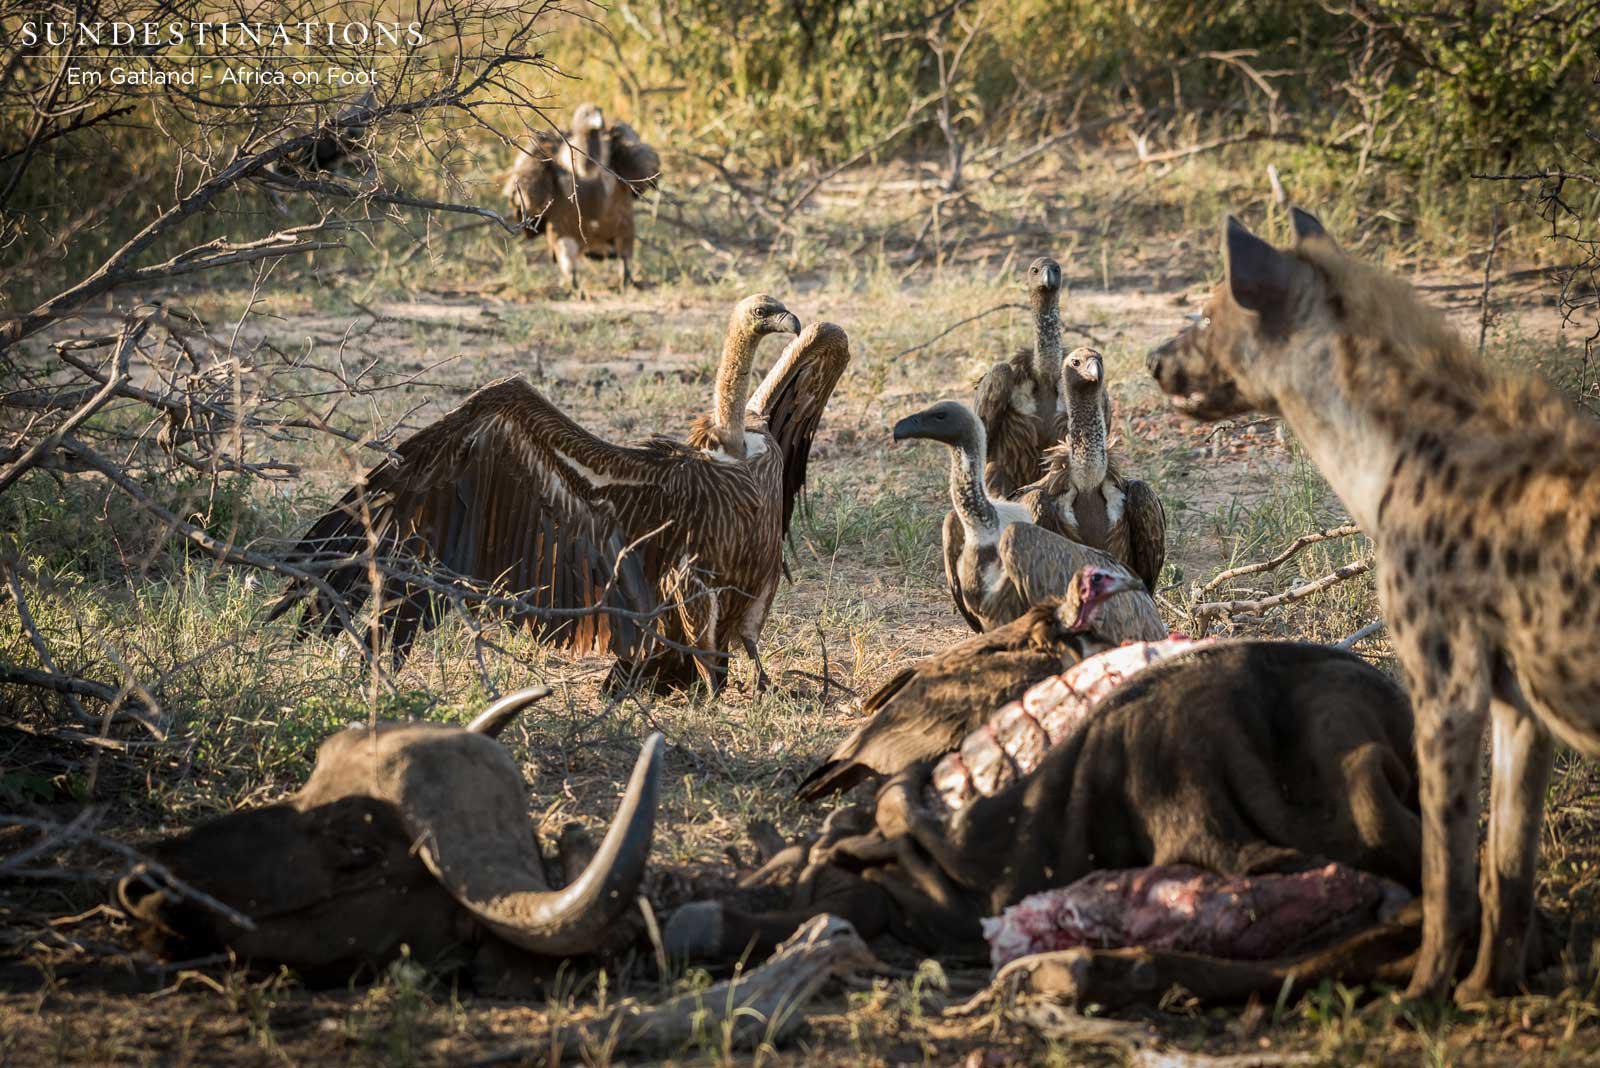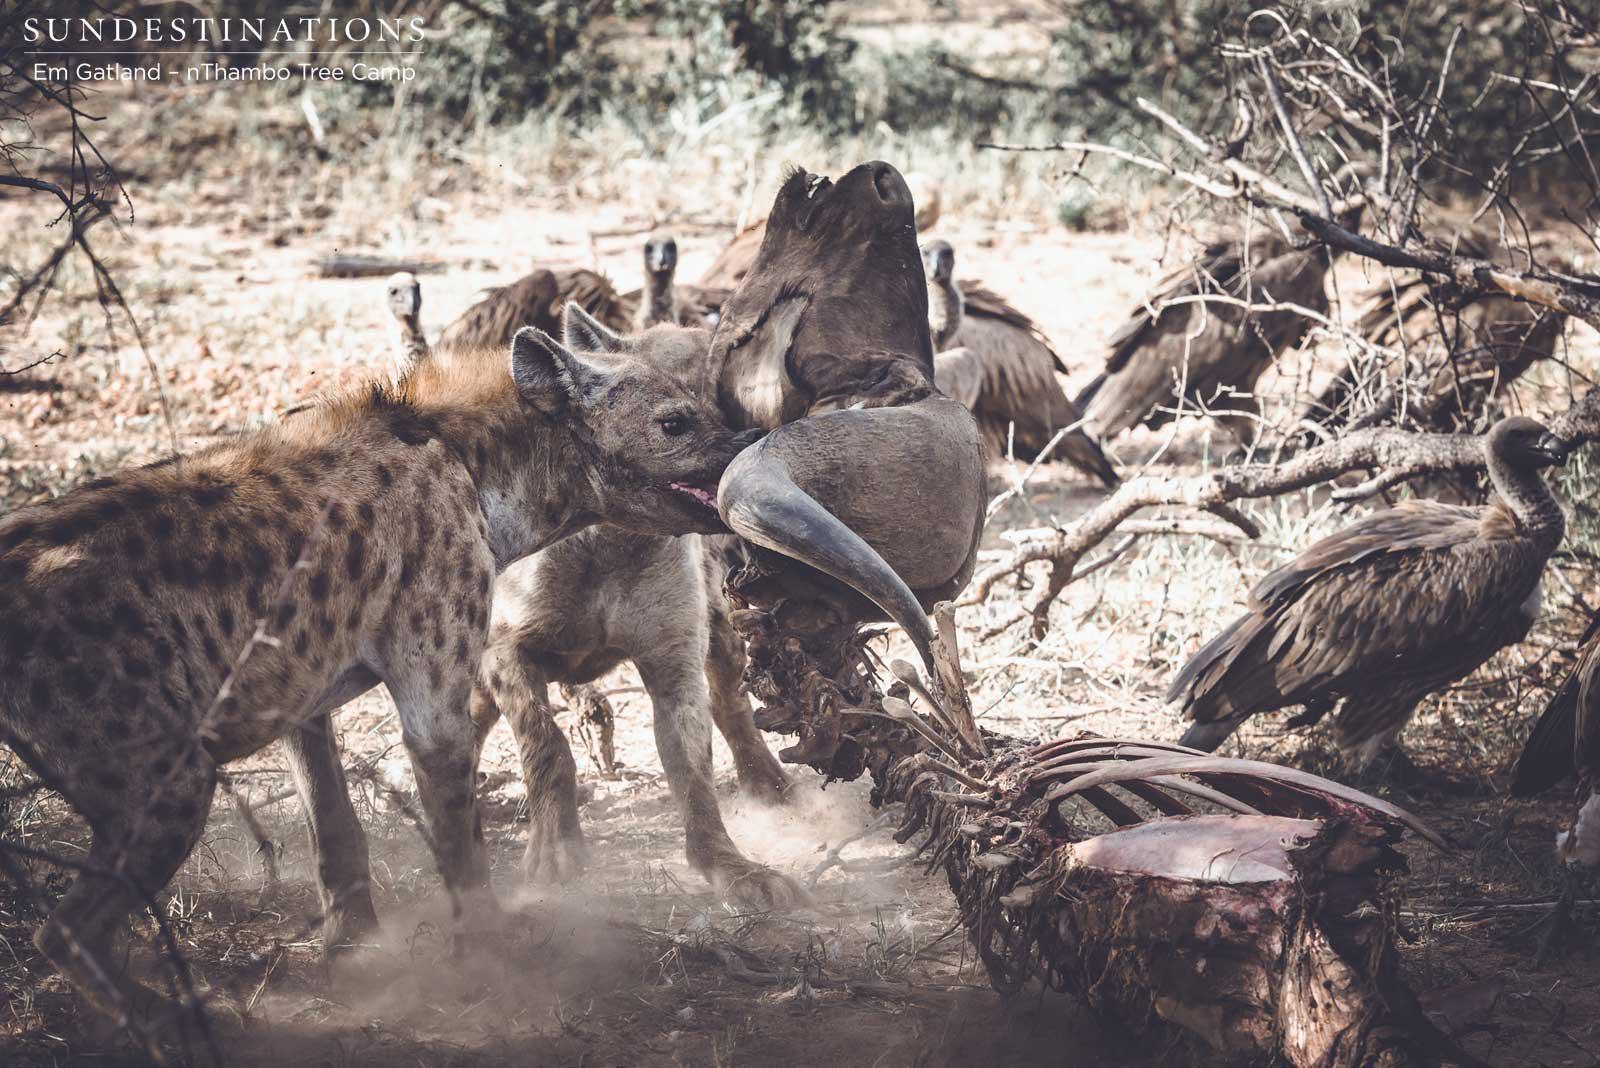The first image is the image on the left, the second image is the image on the right. Considering the images on both sides, is "The right image includes at least one leftward-facing hyena standing in front of a large rock, but does not include a carcass or any other type of animal in the foreground." valid? Answer yes or no. No. The first image is the image on the left, the second image is the image on the right. Assess this claim about the two images: "In at least one image there is a single hyena with its mouth facing the dead prey.". Correct or not? Answer yes or no. No. 